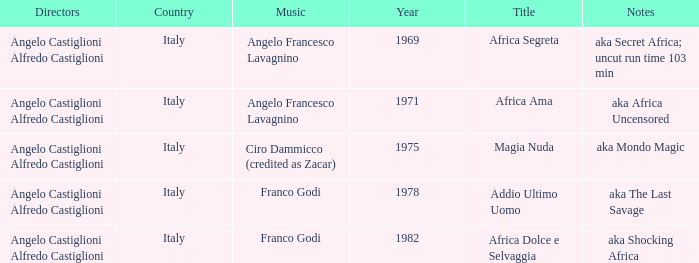What is the country that has a music writer of Angelo Francesco Lavagnino, written in 1969? Italy. Write the full table. {'header': ['Directors', 'Country', 'Music', 'Year', 'Title', 'Notes'], 'rows': [['Angelo Castiglioni Alfredo Castiglioni', 'Italy', 'Angelo Francesco Lavagnino', '1969', 'Africa Segreta', 'aka Secret Africa; uncut run time 103 min'], ['Angelo Castiglioni Alfredo Castiglioni', 'Italy', 'Angelo Francesco Lavagnino', '1971', 'Africa Ama', 'aka Africa Uncensored'], ['Angelo Castiglioni Alfredo Castiglioni', 'Italy', 'Ciro Dammicco (credited as Zacar)', '1975', 'Magia Nuda', 'aka Mondo Magic'], ['Angelo Castiglioni Alfredo Castiglioni', 'Italy', 'Franco Godi', '1978', 'Addio Ultimo Uomo', 'aka The Last Savage'], ['Angelo Castiglioni Alfredo Castiglioni', 'Italy', 'Franco Godi', '1982', 'Africa Dolce e Selvaggia', 'aka Shocking Africa']]} 